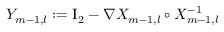<formula> <loc_0><loc_0><loc_500><loc_500>Y _ { m - 1 , l } \colon = { I _ { 2 } } - \nabla X _ { m - 1 , l } \circ X _ { m - 1 , l } ^ { - 1 }</formula> 